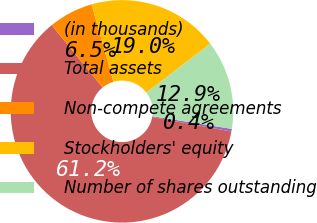Convert chart to OTSL. <chart><loc_0><loc_0><loc_500><loc_500><pie_chart><fcel>(in thousands)<fcel>Total assets<fcel>Non-compete agreements<fcel>Stockholders' equity<fcel>Number of shares outstanding<nl><fcel>0.38%<fcel>61.22%<fcel>6.47%<fcel>19.01%<fcel>12.92%<nl></chart> 